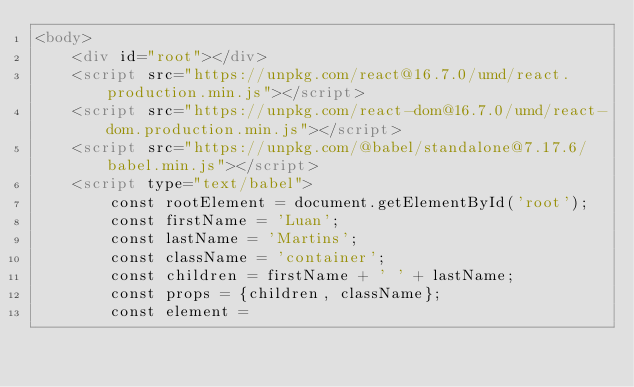<code> <loc_0><loc_0><loc_500><loc_500><_HTML_><body>
    <div id="root"></div>
    <script src="https://unpkg.com/react@16.7.0/umd/react.production.min.js"></script>
    <script src="https://unpkg.com/react-dom@16.7.0/umd/react-dom.production.min.js"></script>
    <script src="https://unpkg.com/@babel/standalone@7.17.6/babel.min.js"></script>
    <script type="text/babel">
        const rootElement = document.getElementById('root');
        const firstName = 'Luan';
        const lastName = 'Martins';
        const className = 'container';
        const children = firstName + ' ' + lastName;
        const props = {children, className};
        const element = </code> 